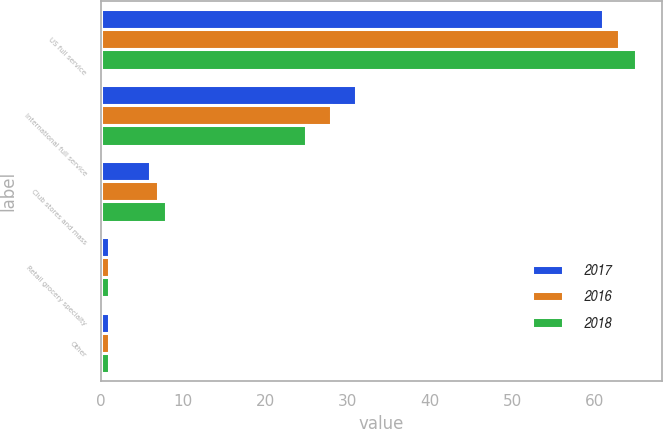Convert chart. <chart><loc_0><loc_0><loc_500><loc_500><stacked_bar_chart><ecel><fcel>US full service<fcel>International full service<fcel>Club stores and mass<fcel>Retail grocery specialty<fcel>Other<nl><fcel>2017<fcel>61<fcel>31<fcel>6<fcel>1<fcel>1<nl><fcel>2016<fcel>63<fcel>28<fcel>7<fcel>1<fcel>1<nl><fcel>2018<fcel>65<fcel>25<fcel>8<fcel>1<fcel>1<nl></chart> 